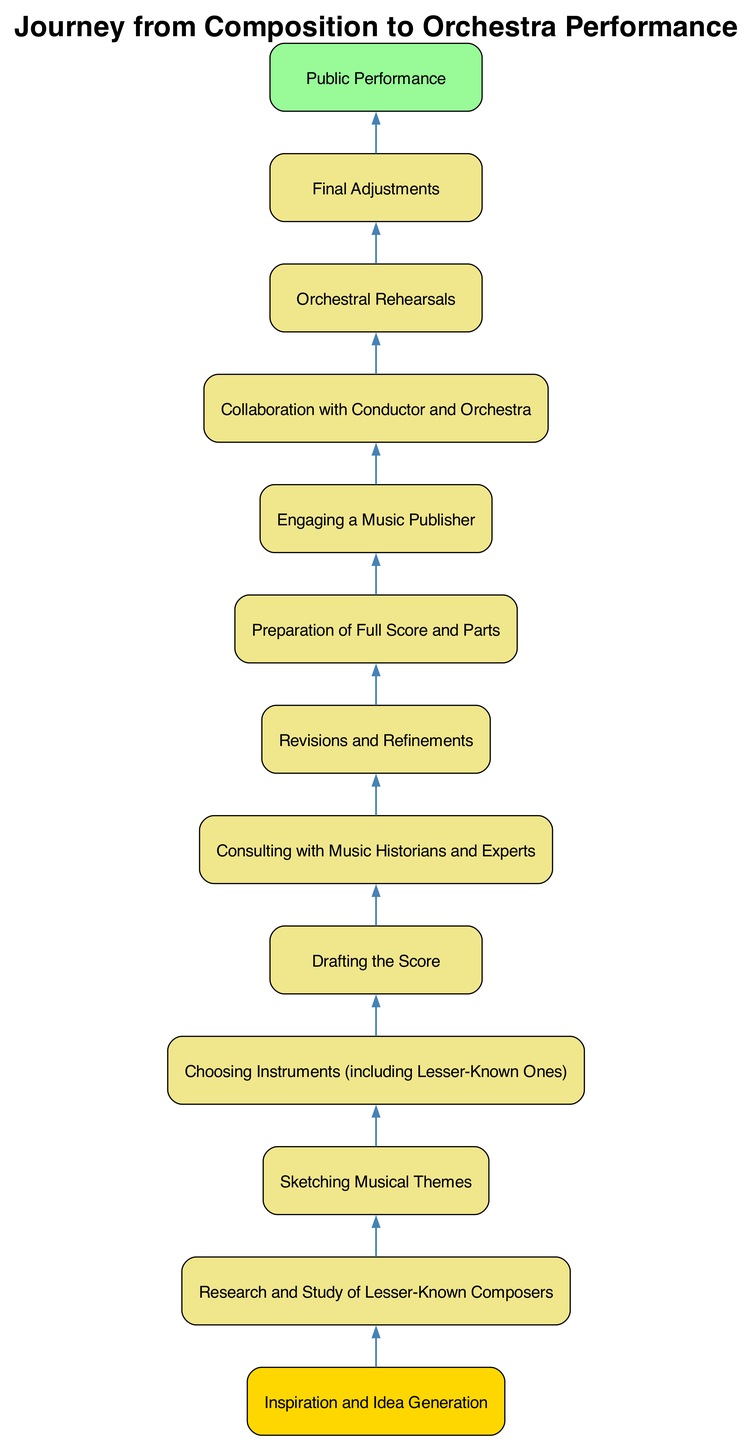What is the first step in the journey? The diagram indicates that the first step in the journey is "Inspiration and Idea Generation." It is positioned at the bottom of the flow chart, indicating it is the starting point.
Answer: Inspiration and Idea Generation How many steps are there in total? The diagram outlines a total of 13 steps, each represented as a node in the flow chart. Counting them from the first step to the last confirms this total.
Answer: 13 What follows after "Collaboration with Conductor and Orchestra"? By examining the flow chart, the step that follows "Collaboration with Conductor and Orchestra" is "Orchestral Rehearsals." The arrows indicate the flow from one step to the next.
Answer: Orchestral Rehearsals Which step involves engaging a music publisher? The specific step that involves engaging a music publisher is labeled as "Engaging a Music Publisher." In the context of the flow, it comes after "Preparation of Full Score and Parts."
Answer: Engaging a Music Publisher What is the final step in the performance journey? The last step in the journey from composition to orchestra performance is "Public Performance," which is located at the top of the flow chart, indicating the conclusion of the process.
Answer: Public Performance Which step requires consulting with experts? The step titled "Consulting with Music Historians and Experts" clearly indicates that this task involves collaboration with knowledgeable individuals, positioned before revisions take place.
Answer: Consulting with Music Historians and Experts What are the two steps before "Final Adjustments"? The two steps that lead up to "Final Adjustments" are "Orchestral Rehearsals" and "Collaboration with Conductor and Orchestra." These precede the final critical adjustments in the workflow.
Answer: Orchestral Rehearsals, Collaboration with Conductor and Orchestra What is the relationship between "Drafting the Score" and "Revisions and Refinements"? The flow chart shows that "Drafting the Score" directly leads to "Revisions and Refinements." This indicates that once a draft is created, it is then reviewed and refined in the next step.
Answer: Directly leads to 